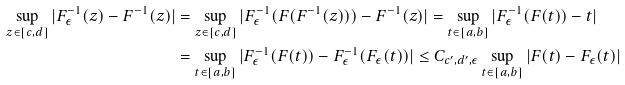<formula> <loc_0><loc_0><loc_500><loc_500>\sup _ { z \in [ c , d ] } | F _ { \epsilon } ^ { - 1 } ( z ) - F ^ { - 1 } ( z ) | & = \sup _ { z \in [ c , d ] } | F _ { \epsilon } ^ { - 1 } ( F ( F ^ { - 1 } ( z ) ) ) - F ^ { - 1 } ( z ) | = \sup _ { t \in [ a , b ] } | F _ { \epsilon } ^ { - 1 } ( F ( t ) ) - t | \\ & = \sup _ { t \in [ a , b ] } | F _ { \epsilon } ^ { - 1 } ( F ( t ) ) - F _ { \epsilon } ^ { - 1 } ( F _ { \epsilon } ( t ) ) | \leq C _ { c ^ { \prime } , d ^ { \prime } , \epsilon } \sup _ { t \in [ a , b ] } | F ( t ) - F _ { \epsilon } ( t ) |</formula> 